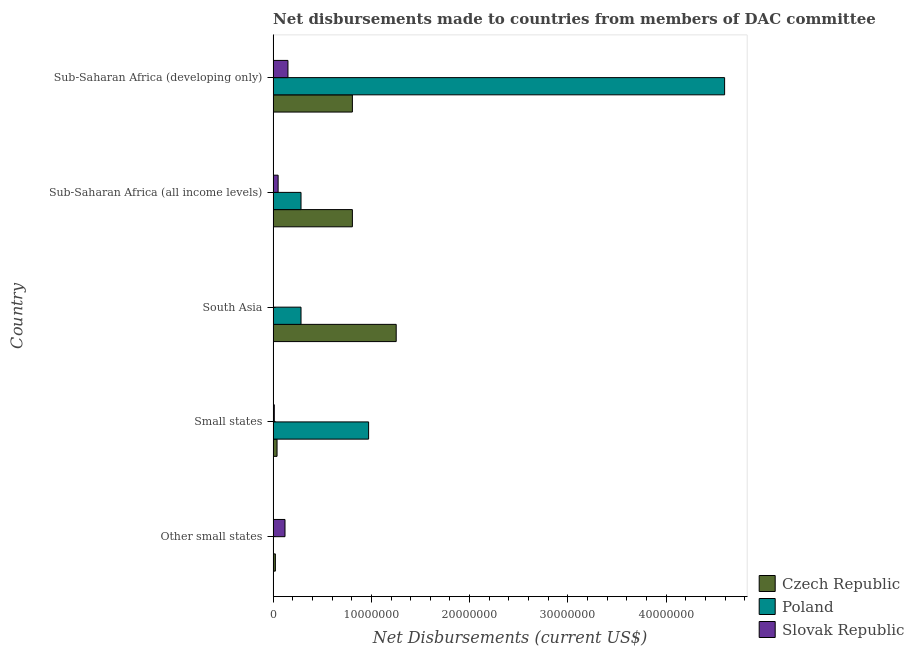How many groups of bars are there?
Your response must be concise. 5. Are the number of bars on each tick of the Y-axis equal?
Provide a succinct answer. No. How many bars are there on the 2nd tick from the top?
Your answer should be very brief. 3. How many bars are there on the 3rd tick from the bottom?
Offer a very short reply. 3. What is the label of the 5th group of bars from the top?
Offer a terse response. Other small states. In how many cases, is the number of bars for a given country not equal to the number of legend labels?
Provide a short and direct response. 1. What is the net disbursements made by czech republic in Other small states?
Give a very brief answer. 2.30e+05. Across all countries, what is the maximum net disbursements made by czech republic?
Provide a succinct answer. 1.25e+07. Across all countries, what is the minimum net disbursements made by czech republic?
Offer a terse response. 2.30e+05. What is the total net disbursements made by poland in the graph?
Offer a very short reply. 6.14e+07. What is the difference between the net disbursements made by czech republic in Small states and that in Sub-Saharan Africa (developing only)?
Offer a very short reply. -7.67e+06. What is the difference between the net disbursements made by czech republic in South Asia and the net disbursements made by poland in Sub-Saharan Africa (all income levels)?
Offer a terse response. 9.69e+06. What is the average net disbursements made by slovak republic per country?
Ensure brevity in your answer.  6.76e+05. What is the difference between the net disbursements made by slovak republic and net disbursements made by czech republic in Sub-Saharan Africa (all income levels)?
Give a very brief answer. -7.56e+06. What is the ratio of the net disbursements made by czech republic in Other small states to that in South Asia?
Provide a short and direct response. 0.02. Is the net disbursements made by slovak republic in Other small states less than that in Sub-Saharan Africa (all income levels)?
Your response must be concise. No. What is the difference between the highest and the second highest net disbursements made by poland?
Ensure brevity in your answer.  3.62e+07. What is the difference between the highest and the lowest net disbursements made by slovak republic?
Keep it short and to the point. 1.48e+06. Is the sum of the net disbursements made by slovak republic in Other small states and Sub-Saharan Africa (developing only) greater than the maximum net disbursements made by poland across all countries?
Offer a very short reply. No. How many bars are there?
Ensure brevity in your answer.  14. Where does the legend appear in the graph?
Provide a succinct answer. Bottom right. How many legend labels are there?
Your answer should be very brief. 3. How are the legend labels stacked?
Your answer should be compact. Vertical. What is the title of the graph?
Ensure brevity in your answer.  Net disbursements made to countries from members of DAC committee. What is the label or title of the X-axis?
Ensure brevity in your answer.  Net Disbursements (current US$). What is the Net Disbursements (current US$) of Czech Republic in Other small states?
Your answer should be very brief. 2.30e+05. What is the Net Disbursements (current US$) of Slovak Republic in Other small states?
Provide a short and direct response. 1.21e+06. What is the Net Disbursements (current US$) of Poland in Small states?
Give a very brief answer. 9.72e+06. What is the Net Disbursements (current US$) of Czech Republic in South Asia?
Your answer should be very brief. 1.25e+07. What is the Net Disbursements (current US$) in Poland in South Asia?
Ensure brevity in your answer.  2.84e+06. What is the Net Disbursements (current US$) of Czech Republic in Sub-Saharan Africa (all income levels)?
Your answer should be compact. 8.07e+06. What is the Net Disbursements (current US$) of Poland in Sub-Saharan Africa (all income levels)?
Provide a succinct answer. 2.84e+06. What is the Net Disbursements (current US$) of Slovak Republic in Sub-Saharan Africa (all income levels)?
Keep it short and to the point. 5.10e+05. What is the Net Disbursements (current US$) of Czech Republic in Sub-Saharan Africa (developing only)?
Ensure brevity in your answer.  8.07e+06. What is the Net Disbursements (current US$) in Poland in Sub-Saharan Africa (developing only)?
Ensure brevity in your answer.  4.60e+07. What is the Net Disbursements (current US$) of Slovak Republic in Sub-Saharan Africa (developing only)?
Offer a terse response. 1.51e+06. Across all countries, what is the maximum Net Disbursements (current US$) in Czech Republic?
Offer a terse response. 1.25e+07. Across all countries, what is the maximum Net Disbursements (current US$) of Poland?
Keep it short and to the point. 4.60e+07. Across all countries, what is the maximum Net Disbursements (current US$) of Slovak Republic?
Offer a terse response. 1.51e+06. Across all countries, what is the minimum Net Disbursements (current US$) in Czech Republic?
Your response must be concise. 2.30e+05. Across all countries, what is the minimum Net Disbursements (current US$) in Slovak Republic?
Offer a very short reply. 3.00e+04. What is the total Net Disbursements (current US$) in Czech Republic in the graph?
Ensure brevity in your answer.  2.93e+07. What is the total Net Disbursements (current US$) in Poland in the graph?
Ensure brevity in your answer.  6.14e+07. What is the total Net Disbursements (current US$) of Slovak Republic in the graph?
Keep it short and to the point. 3.38e+06. What is the difference between the Net Disbursements (current US$) in Czech Republic in Other small states and that in Small states?
Ensure brevity in your answer.  -1.70e+05. What is the difference between the Net Disbursements (current US$) of Slovak Republic in Other small states and that in Small states?
Offer a terse response. 1.09e+06. What is the difference between the Net Disbursements (current US$) of Czech Republic in Other small states and that in South Asia?
Offer a very short reply. -1.23e+07. What is the difference between the Net Disbursements (current US$) of Slovak Republic in Other small states and that in South Asia?
Your answer should be very brief. 1.18e+06. What is the difference between the Net Disbursements (current US$) of Czech Republic in Other small states and that in Sub-Saharan Africa (all income levels)?
Your response must be concise. -7.84e+06. What is the difference between the Net Disbursements (current US$) of Czech Republic in Other small states and that in Sub-Saharan Africa (developing only)?
Your answer should be compact. -7.84e+06. What is the difference between the Net Disbursements (current US$) of Czech Republic in Small states and that in South Asia?
Give a very brief answer. -1.21e+07. What is the difference between the Net Disbursements (current US$) of Poland in Small states and that in South Asia?
Provide a succinct answer. 6.88e+06. What is the difference between the Net Disbursements (current US$) of Czech Republic in Small states and that in Sub-Saharan Africa (all income levels)?
Ensure brevity in your answer.  -7.67e+06. What is the difference between the Net Disbursements (current US$) of Poland in Small states and that in Sub-Saharan Africa (all income levels)?
Make the answer very short. 6.88e+06. What is the difference between the Net Disbursements (current US$) in Slovak Republic in Small states and that in Sub-Saharan Africa (all income levels)?
Give a very brief answer. -3.90e+05. What is the difference between the Net Disbursements (current US$) in Czech Republic in Small states and that in Sub-Saharan Africa (developing only)?
Your response must be concise. -7.67e+06. What is the difference between the Net Disbursements (current US$) of Poland in Small states and that in Sub-Saharan Africa (developing only)?
Keep it short and to the point. -3.62e+07. What is the difference between the Net Disbursements (current US$) of Slovak Republic in Small states and that in Sub-Saharan Africa (developing only)?
Offer a very short reply. -1.39e+06. What is the difference between the Net Disbursements (current US$) of Czech Republic in South Asia and that in Sub-Saharan Africa (all income levels)?
Your answer should be very brief. 4.46e+06. What is the difference between the Net Disbursements (current US$) in Poland in South Asia and that in Sub-Saharan Africa (all income levels)?
Keep it short and to the point. 0. What is the difference between the Net Disbursements (current US$) in Slovak Republic in South Asia and that in Sub-Saharan Africa (all income levels)?
Your answer should be very brief. -4.80e+05. What is the difference between the Net Disbursements (current US$) of Czech Republic in South Asia and that in Sub-Saharan Africa (developing only)?
Give a very brief answer. 4.46e+06. What is the difference between the Net Disbursements (current US$) of Poland in South Asia and that in Sub-Saharan Africa (developing only)?
Give a very brief answer. -4.31e+07. What is the difference between the Net Disbursements (current US$) in Slovak Republic in South Asia and that in Sub-Saharan Africa (developing only)?
Your response must be concise. -1.48e+06. What is the difference between the Net Disbursements (current US$) of Czech Republic in Sub-Saharan Africa (all income levels) and that in Sub-Saharan Africa (developing only)?
Provide a short and direct response. 0. What is the difference between the Net Disbursements (current US$) of Poland in Sub-Saharan Africa (all income levels) and that in Sub-Saharan Africa (developing only)?
Offer a terse response. -4.31e+07. What is the difference between the Net Disbursements (current US$) in Czech Republic in Other small states and the Net Disbursements (current US$) in Poland in Small states?
Make the answer very short. -9.49e+06. What is the difference between the Net Disbursements (current US$) of Czech Republic in Other small states and the Net Disbursements (current US$) of Poland in South Asia?
Provide a short and direct response. -2.61e+06. What is the difference between the Net Disbursements (current US$) in Czech Republic in Other small states and the Net Disbursements (current US$) in Slovak Republic in South Asia?
Provide a succinct answer. 2.00e+05. What is the difference between the Net Disbursements (current US$) in Czech Republic in Other small states and the Net Disbursements (current US$) in Poland in Sub-Saharan Africa (all income levels)?
Give a very brief answer. -2.61e+06. What is the difference between the Net Disbursements (current US$) of Czech Republic in Other small states and the Net Disbursements (current US$) of Slovak Republic in Sub-Saharan Africa (all income levels)?
Keep it short and to the point. -2.80e+05. What is the difference between the Net Disbursements (current US$) in Czech Republic in Other small states and the Net Disbursements (current US$) in Poland in Sub-Saharan Africa (developing only)?
Your answer should be very brief. -4.57e+07. What is the difference between the Net Disbursements (current US$) of Czech Republic in Other small states and the Net Disbursements (current US$) of Slovak Republic in Sub-Saharan Africa (developing only)?
Provide a short and direct response. -1.28e+06. What is the difference between the Net Disbursements (current US$) of Czech Republic in Small states and the Net Disbursements (current US$) of Poland in South Asia?
Your answer should be compact. -2.44e+06. What is the difference between the Net Disbursements (current US$) in Czech Republic in Small states and the Net Disbursements (current US$) in Slovak Republic in South Asia?
Your answer should be very brief. 3.70e+05. What is the difference between the Net Disbursements (current US$) of Poland in Small states and the Net Disbursements (current US$) of Slovak Republic in South Asia?
Your answer should be very brief. 9.69e+06. What is the difference between the Net Disbursements (current US$) of Czech Republic in Small states and the Net Disbursements (current US$) of Poland in Sub-Saharan Africa (all income levels)?
Ensure brevity in your answer.  -2.44e+06. What is the difference between the Net Disbursements (current US$) in Czech Republic in Small states and the Net Disbursements (current US$) in Slovak Republic in Sub-Saharan Africa (all income levels)?
Your answer should be very brief. -1.10e+05. What is the difference between the Net Disbursements (current US$) of Poland in Small states and the Net Disbursements (current US$) of Slovak Republic in Sub-Saharan Africa (all income levels)?
Provide a short and direct response. 9.21e+06. What is the difference between the Net Disbursements (current US$) in Czech Republic in Small states and the Net Disbursements (current US$) in Poland in Sub-Saharan Africa (developing only)?
Keep it short and to the point. -4.56e+07. What is the difference between the Net Disbursements (current US$) of Czech Republic in Small states and the Net Disbursements (current US$) of Slovak Republic in Sub-Saharan Africa (developing only)?
Make the answer very short. -1.11e+06. What is the difference between the Net Disbursements (current US$) of Poland in Small states and the Net Disbursements (current US$) of Slovak Republic in Sub-Saharan Africa (developing only)?
Your response must be concise. 8.21e+06. What is the difference between the Net Disbursements (current US$) of Czech Republic in South Asia and the Net Disbursements (current US$) of Poland in Sub-Saharan Africa (all income levels)?
Offer a very short reply. 9.69e+06. What is the difference between the Net Disbursements (current US$) in Czech Republic in South Asia and the Net Disbursements (current US$) in Slovak Republic in Sub-Saharan Africa (all income levels)?
Your answer should be compact. 1.20e+07. What is the difference between the Net Disbursements (current US$) in Poland in South Asia and the Net Disbursements (current US$) in Slovak Republic in Sub-Saharan Africa (all income levels)?
Provide a short and direct response. 2.33e+06. What is the difference between the Net Disbursements (current US$) of Czech Republic in South Asia and the Net Disbursements (current US$) of Poland in Sub-Saharan Africa (developing only)?
Provide a short and direct response. -3.34e+07. What is the difference between the Net Disbursements (current US$) of Czech Republic in South Asia and the Net Disbursements (current US$) of Slovak Republic in Sub-Saharan Africa (developing only)?
Provide a succinct answer. 1.10e+07. What is the difference between the Net Disbursements (current US$) in Poland in South Asia and the Net Disbursements (current US$) in Slovak Republic in Sub-Saharan Africa (developing only)?
Offer a terse response. 1.33e+06. What is the difference between the Net Disbursements (current US$) in Czech Republic in Sub-Saharan Africa (all income levels) and the Net Disbursements (current US$) in Poland in Sub-Saharan Africa (developing only)?
Offer a very short reply. -3.79e+07. What is the difference between the Net Disbursements (current US$) of Czech Republic in Sub-Saharan Africa (all income levels) and the Net Disbursements (current US$) of Slovak Republic in Sub-Saharan Africa (developing only)?
Give a very brief answer. 6.56e+06. What is the difference between the Net Disbursements (current US$) in Poland in Sub-Saharan Africa (all income levels) and the Net Disbursements (current US$) in Slovak Republic in Sub-Saharan Africa (developing only)?
Ensure brevity in your answer.  1.33e+06. What is the average Net Disbursements (current US$) of Czech Republic per country?
Make the answer very short. 5.86e+06. What is the average Net Disbursements (current US$) in Poland per country?
Your answer should be compact. 1.23e+07. What is the average Net Disbursements (current US$) in Slovak Republic per country?
Ensure brevity in your answer.  6.76e+05. What is the difference between the Net Disbursements (current US$) in Czech Republic and Net Disbursements (current US$) in Slovak Republic in Other small states?
Offer a very short reply. -9.80e+05. What is the difference between the Net Disbursements (current US$) in Czech Republic and Net Disbursements (current US$) in Poland in Small states?
Ensure brevity in your answer.  -9.32e+06. What is the difference between the Net Disbursements (current US$) in Poland and Net Disbursements (current US$) in Slovak Republic in Small states?
Give a very brief answer. 9.60e+06. What is the difference between the Net Disbursements (current US$) of Czech Republic and Net Disbursements (current US$) of Poland in South Asia?
Provide a succinct answer. 9.69e+06. What is the difference between the Net Disbursements (current US$) of Czech Republic and Net Disbursements (current US$) of Slovak Republic in South Asia?
Your answer should be very brief. 1.25e+07. What is the difference between the Net Disbursements (current US$) of Poland and Net Disbursements (current US$) of Slovak Republic in South Asia?
Keep it short and to the point. 2.81e+06. What is the difference between the Net Disbursements (current US$) of Czech Republic and Net Disbursements (current US$) of Poland in Sub-Saharan Africa (all income levels)?
Ensure brevity in your answer.  5.23e+06. What is the difference between the Net Disbursements (current US$) of Czech Republic and Net Disbursements (current US$) of Slovak Republic in Sub-Saharan Africa (all income levels)?
Your answer should be very brief. 7.56e+06. What is the difference between the Net Disbursements (current US$) of Poland and Net Disbursements (current US$) of Slovak Republic in Sub-Saharan Africa (all income levels)?
Your response must be concise. 2.33e+06. What is the difference between the Net Disbursements (current US$) in Czech Republic and Net Disbursements (current US$) in Poland in Sub-Saharan Africa (developing only)?
Offer a terse response. -3.79e+07. What is the difference between the Net Disbursements (current US$) in Czech Republic and Net Disbursements (current US$) in Slovak Republic in Sub-Saharan Africa (developing only)?
Your answer should be compact. 6.56e+06. What is the difference between the Net Disbursements (current US$) of Poland and Net Disbursements (current US$) of Slovak Republic in Sub-Saharan Africa (developing only)?
Provide a short and direct response. 4.44e+07. What is the ratio of the Net Disbursements (current US$) in Czech Republic in Other small states to that in Small states?
Provide a short and direct response. 0.57. What is the ratio of the Net Disbursements (current US$) in Slovak Republic in Other small states to that in Small states?
Offer a very short reply. 10.08. What is the ratio of the Net Disbursements (current US$) in Czech Republic in Other small states to that in South Asia?
Make the answer very short. 0.02. What is the ratio of the Net Disbursements (current US$) of Slovak Republic in Other small states to that in South Asia?
Keep it short and to the point. 40.33. What is the ratio of the Net Disbursements (current US$) in Czech Republic in Other small states to that in Sub-Saharan Africa (all income levels)?
Your answer should be very brief. 0.03. What is the ratio of the Net Disbursements (current US$) in Slovak Republic in Other small states to that in Sub-Saharan Africa (all income levels)?
Give a very brief answer. 2.37. What is the ratio of the Net Disbursements (current US$) of Czech Republic in Other small states to that in Sub-Saharan Africa (developing only)?
Your response must be concise. 0.03. What is the ratio of the Net Disbursements (current US$) of Slovak Republic in Other small states to that in Sub-Saharan Africa (developing only)?
Keep it short and to the point. 0.8. What is the ratio of the Net Disbursements (current US$) of Czech Republic in Small states to that in South Asia?
Make the answer very short. 0.03. What is the ratio of the Net Disbursements (current US$) of Poland in Small states to that in South Asia?
Your response must be concise. 3.42. What is the ratio of the Net Disbursements (current US$) in Slovak Republic in Small states to that in South Asia?
Ensure brevity in your answer.  4. What is the ratio of the Net Disbursements (current US$) in Czech Republic in Small states to that in Sub-Saharan Africa (all income levels)?
Your answer should be compact. 0.05. What is the ratio of the Net Disbursements (current US$) in Poland in Small states to that in Sub-Saharan Africa (all income levels)?
Offer a terse response. 3.42. What is the ratio of the Net Disbursements (current US$) of Slovak Republic in Small states to that in Sub-Saharan Africa (all income levels)?
Give a very brief answer. 0.24. What is the ratio of the Net Disbursements (current US$) of Czech Republic in Small states to that in Sub-Saharan Africa (developing only)?
Your response must be concise. 0.05. What is the ratio of the Net Disbursements (current US$) in Poland in Small states to that in Sub-Saharan Africa (developing only)?
Ensure brevity in your answer.  0.21. What is the ratio of the Net Disbursements (current US$) of Slovak Republic in Small states to that in Sub-Saharan Africa (developing only)?
Your response must be concise. 0.08. What is the ratio of the Net Disbursements (current US$) of Czech Republic in South Asia to that in Sub-Saharan Africa (all income levels)?
Your response must be concise. 1.55. What is the ratio of the Net Disbursements (current US$) of Poland in South Asia to that in Sub-Saharan Africa (all income levels)?
Your answer should be very brief. 1. What is the ratio of the Net Disbursements (current US$) of Slovak Republic in South Asia to that in Sub-Saharan Africa (all income levels)?
Give a very brief answer. 0.06. What is the ratio of the Net Disbursements (current US$) of Czech Republic in South Asia to that in Sub-Saharan Africa (developing only)?
Make the answer very short. 1.55. What is the ratio of the Net Disbursements (current US$) in Poland in South Asia to that in Sub-Saharan Africa (developing only)?
Give a very brief answer. 0.06. What is the ratio of the Net Disbursements (current US$) of Slovak Republic in South Asia to that in Sub-Saharan Africa (developing only)?
Provide a short and direct response. 0.02. What is the ratio of the Net Disbursements (current US$) in Poland in Sub-Saharan Africa (all income levels) to that in Sub-Saharan Africa (developing only)?
Make the answer very short. 0.06. What is the ratio of the Net Disbursements (current US$) in Slovak Republic in Sub-Saharan Africa (all income levels) to that in Sub-Saharan Africa (developing only)?
Provide a short and direct response. 0.34. What is the difference between the highest and the second highest Net Disbursements (current US$) of Czech Republic?
Your response must be concise. 4.46e+06. What is the difference between the highest and the second highest Net Disbursements (current US$) in Poland?
Offer a very short reply. 3.62e+07. What is the difference between the highest and the second highest Net Disbursements (current US$) in Slovak Republic?
Offer a terse response. 3.00e+05. What is the difference between the highest and the lowest Net Disbursements (current US$) of Czech Republic?
Ensure brevity in your answer.  1.23e+07. What is the difference between the highest and the lowest Net Disbursements (current US$) of Poland?
Provide a short and direct response. 4.60e+07. What is the difference between the highest and the lowest Net Disbursements (current US$) in Slovak Republic?
Ensure brevity in your answer.  1.48e+06. 